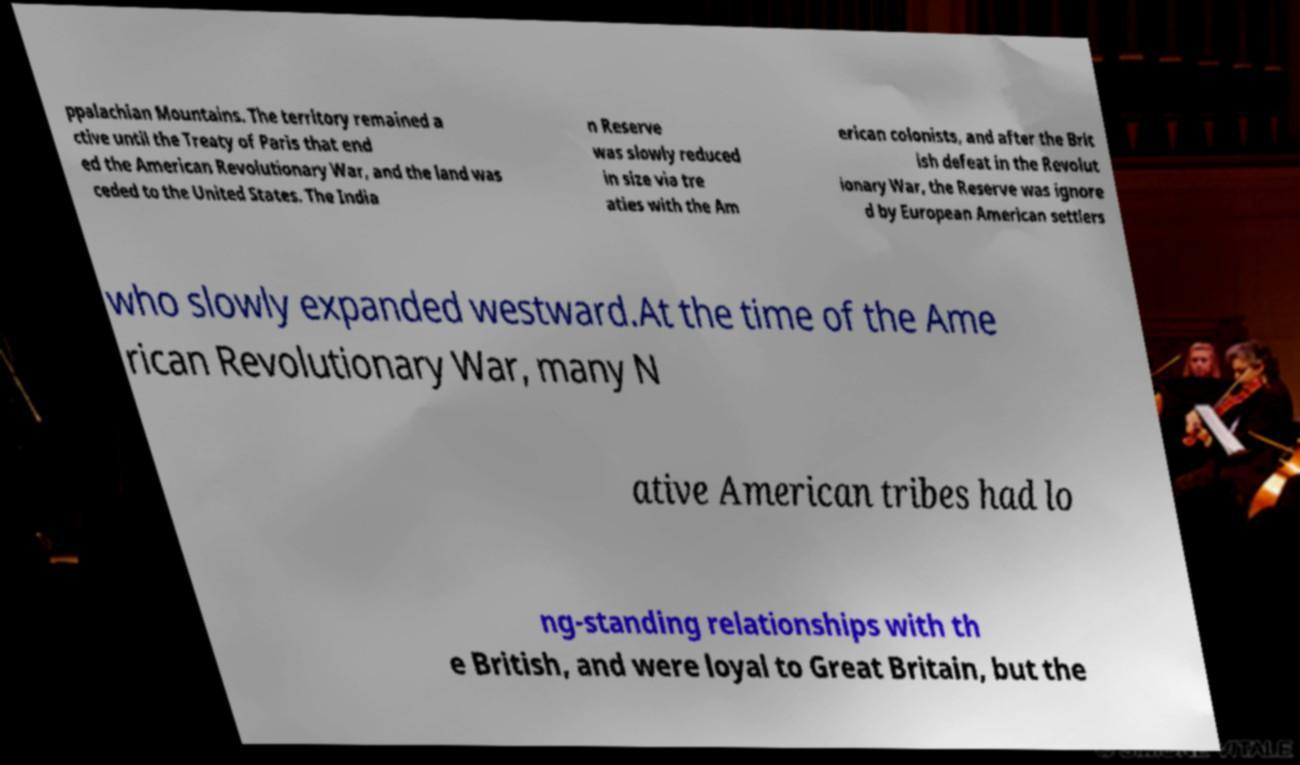What messages or text are displayed in this image? I need them in a readable, typed format. ppalachian Mountains. The territory remained a ctive until the Treaty of Paris that end ed the American Revolutionary War, and the land was ceded to the United States. The India n Reserve was slowly reduced in size via tre aties with the Am erican colonists, and after the Brit ish defeat in the Revolut ionary War, the Reserve was ignore d by European American settlers who slowly expanded westward.At the time of the Ame rican Revolutionary War, many N ative American tribes had lo ng-standing relationships with th e British, and were loyal to Great Britain, but the 